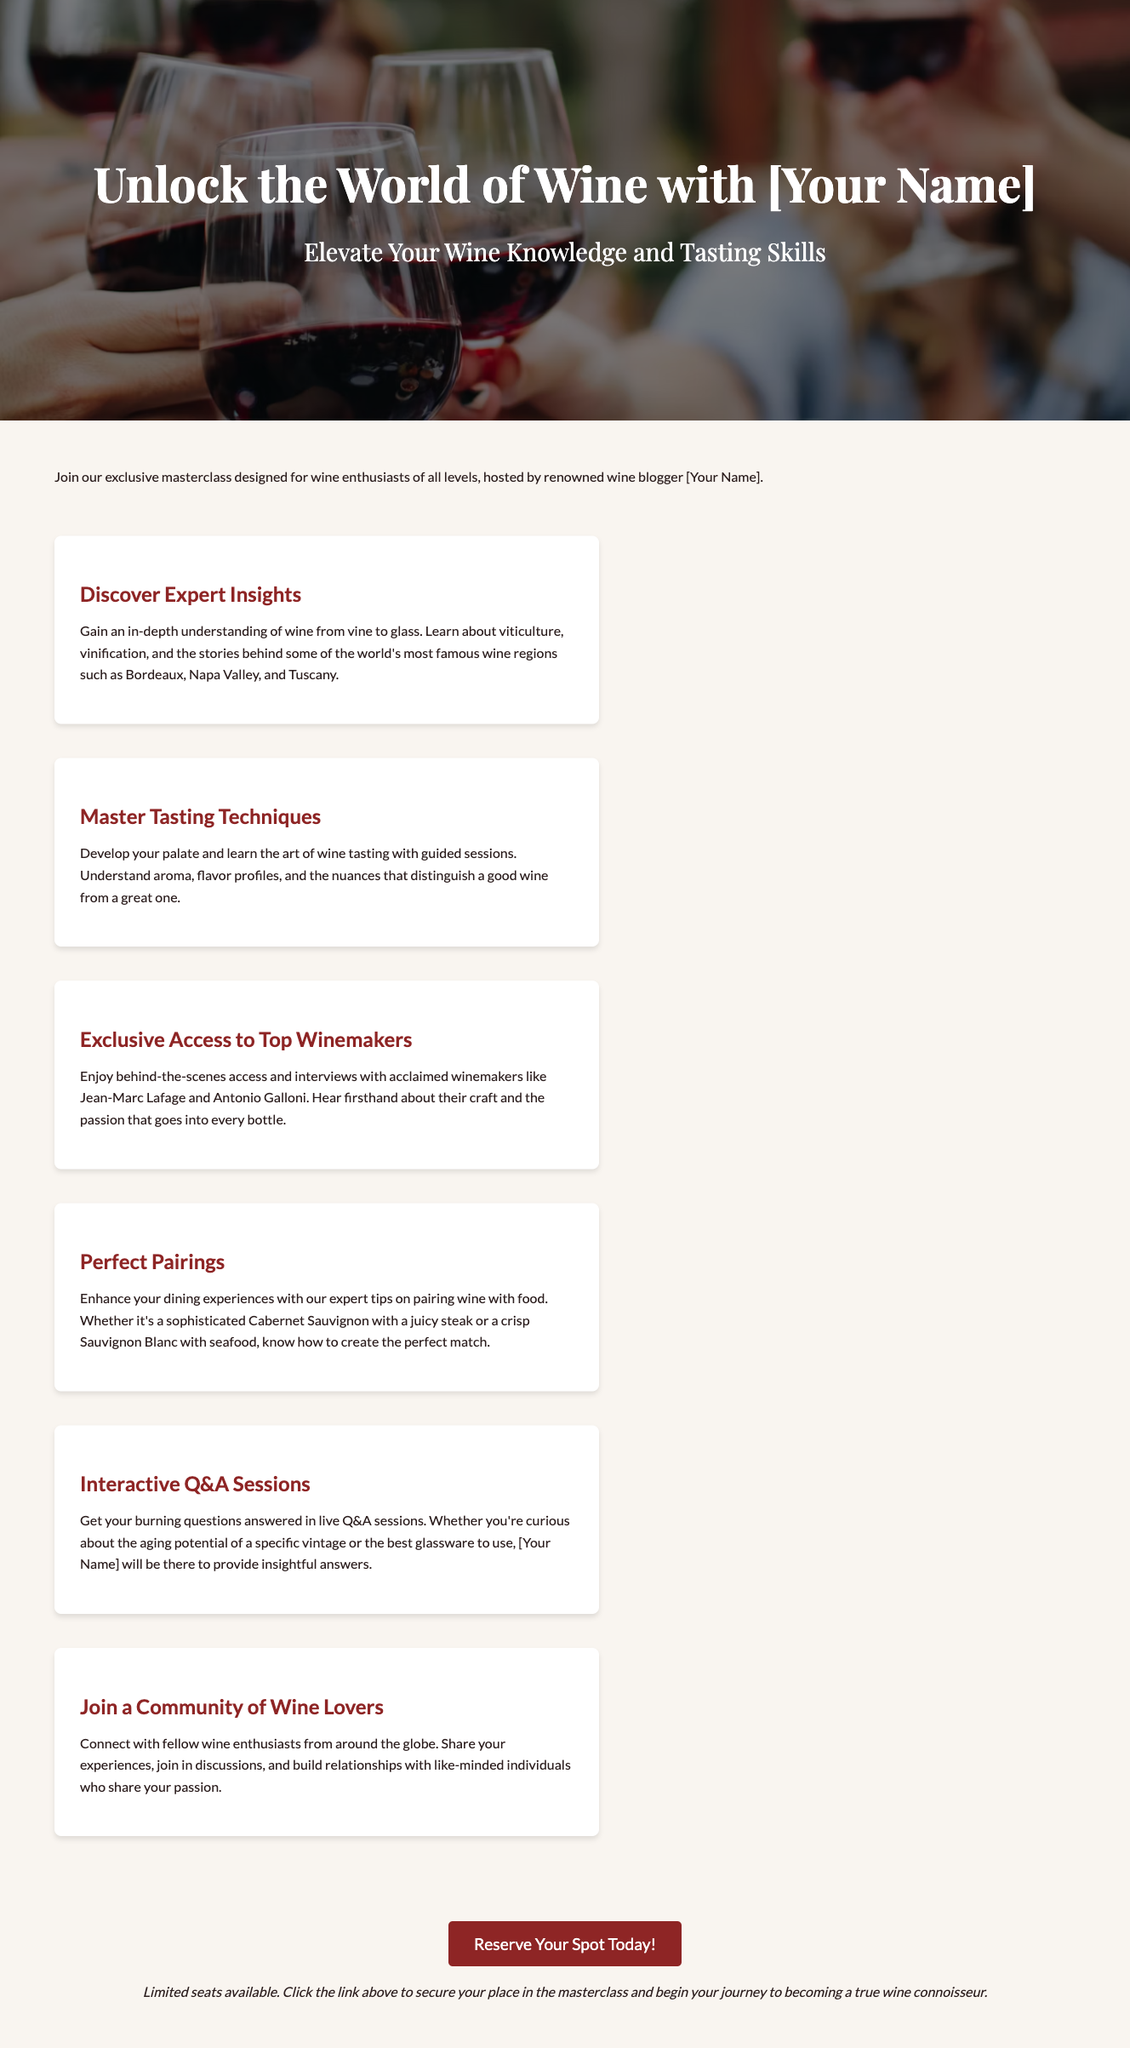What is the title of the masterclass? The title of the masterclass is provided in the header section of the document.
Answer: Unlock the World of Wine with [Your Name] Who is the host of the masterclass? The document specifies the host of the masterclass in the introductory paragraph.
Answer: [Your Name] What regions are mentioned in the document? The document lists several wine regions in the section about expert insights.
Answer: Bordeaux, Napa Valley, Tuscany How many sections are there in the content? The document is structured with six distinct sections of content.
Answer: Six What type of sessions will be included? The document highlights the interactive components of the masterclass, specifically live Q&A sessions.
Answer: Interactive Q&A Sessions What is the call to action for the masterclass? The document concludes with a clear call to action about reserving a spot.
Answer: Reserve Your Spot Today! What is the primary focus of the masterclass? The introductory paragraph explains the main goal of the masterclass aimed at wine enthusiasts.
Answer: Elevate Your Wine Knowledge and Tasting Skills How can participants enhance their dining experiences? The document mentions tips for pairing wine with food in one of the sections.
Answer: Perfect Pairings What is the benefit of joining this masterclass? The advantages of attending are detailed in the various sections, emphasizing community and knowledge.
Answer: Join a Community of Wine Lovers 